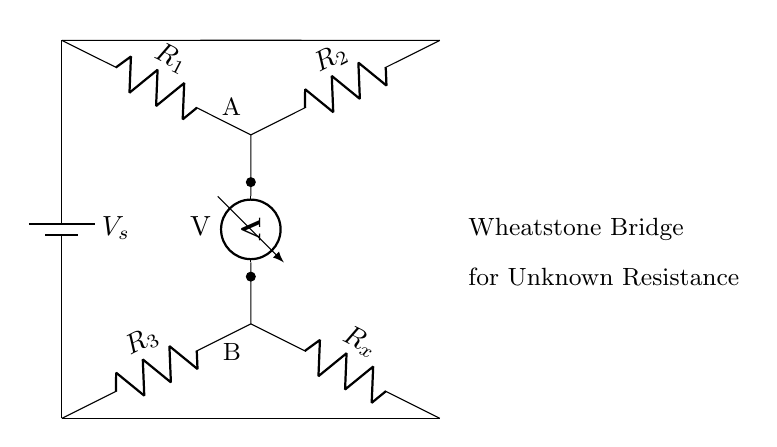What components are used in this Wheatstone bridge? The circuit includes a battery, three resistors labeled \(R_1\), \(R_2\), and \(R_3\), and an unknown resistor labeled \(R_x\). These components are standard for a Wheatstone bridge circuit used for measuring resistance.
Answer: battery, \(R_1\), \(R_2\), \(R_3\), \(R_x\) What is the role of the voltmeter in this circuit? The voltmeter is connected between points A and B to measure the potential difference across the resistances, which helps determine if the bridge is balanced or not, indicating the value of the unknown resistance \(R_x\).
Answer: Measure voltage How many resistors are present in the circuit? The circuit includes four resistors: \(R_1\), \(R_2\), \(R_3\), and \(R_x\). They are arranged in a specific configuration essential for the Wheatstone bridge operation.
Answer: Four What condition makes the Wheatstone bridge balanced? The bridge is balanced when the ratio of resistances \(R_1/R_2\) equals the ratio \(R_3/R_x\), resulting in zero voltage across the voltmeter. This condition allows for the precise calculation of the unknown resistance \(R_x\).
Answer: Equal ratios What type of circuit is this? This is a Wheatstone bridge circuit, specifically designed for measuring unknown resistances by balancing two legs of a bridge circuit. This type of circuit configuration is particular to precision measurement applications.
Answer: Wheatstone bridge 